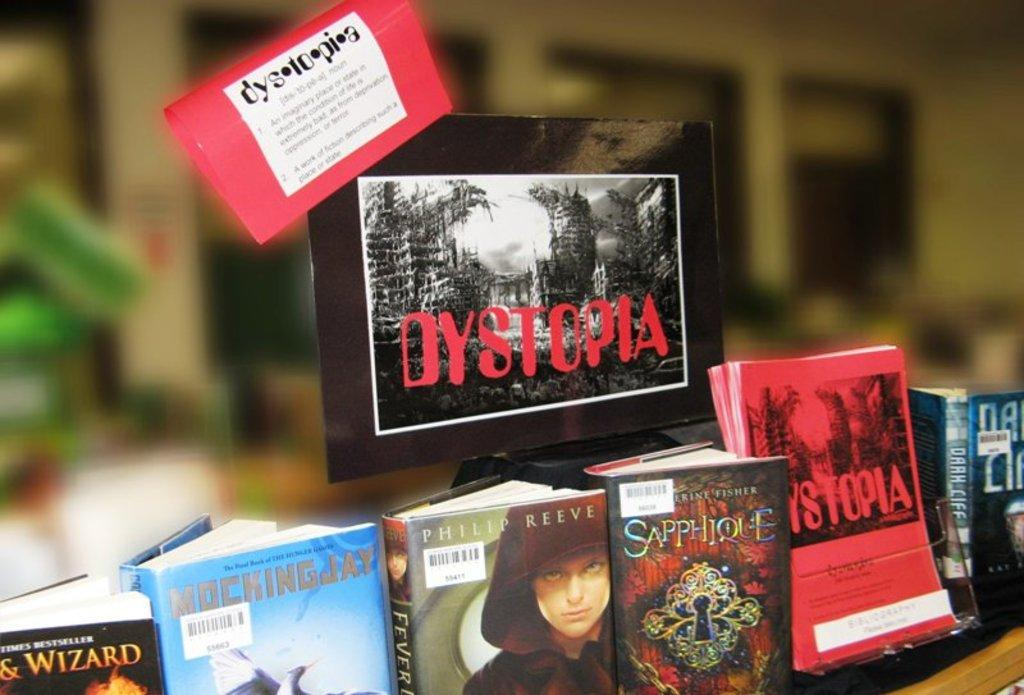What objects can be seen in the image? There are books and a frame visible in the image. Can you describe the frame in the image? Unfortunately, the provided facts do not give any details about the frame. What might the books be used for? The books might be used for reading or studying. How many doors can be seen in the image? There are no doors visible in the image. Is there a cobweb present in the image? There is no mention of a cobweb in the provided facts, so it cannot be determined from the image. What type of vehicle is being driven in the image? There is no vehicle present in the image. 